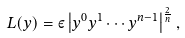Convert formula to latex. <formula><loc_0><loc_0><loc_500><loc_500>L ( y ) = \varepsilon \left | y ^ { 0 } y ^ { 1 } \cdots y ^ { n - 1 } \right | ^ { \frac { 2 } { n } } ,</formula> 